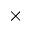<formula> <loc_0><loc_0><loc_500><loc_500>\times</formula> 